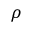Convert formula to latex. <formula><loc_0><loc_0><loc_500><loc_500>\rho</formula> 